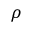Convert formula to latex. <formula><loc_0><loc_0><loc_500><loc_500>\rho</formula> 